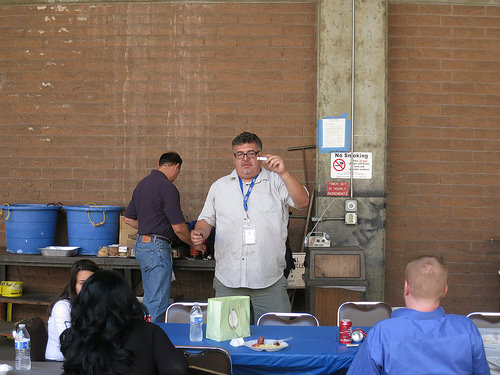<image>
Can you confirm if the woman is behind the table? Yes. From this viewpoint, the woman is positioned behind the table, with the table partially or fully occluding the woman. 